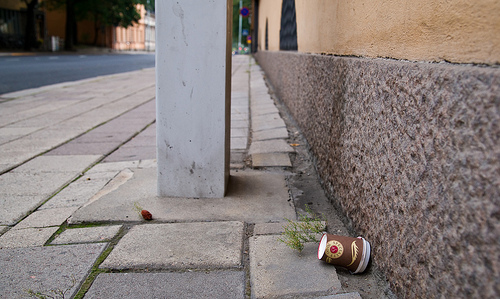<image>
Can you confirm if the cup is on the ground? Yes. Looking at the image, I can see the cup is positioned on top of the ground, with the ground providing support. Is the coffee cup behind the weed? Yes. From this viewpoint, the coffee cup is positioned behind the weed, with the weed partially or fully occluding the coffee cup. 